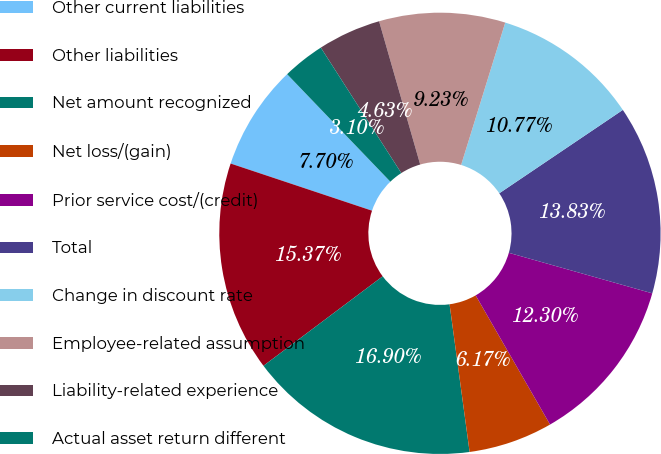Convert chart. <chart><loc_0><loc_0><loc_500><loc_500><pie_chart><fcel>Other current liabilities<fcel>Other liabilities<fcel>Net amount recognized<fcel>Net loss/(gain)<fcel>Prior service cost/(credit)<fcel>Total<fcel>Change in discount rate<fcel>Employee-related assumption<fcel>Liability-related experience<fcel>Actual asset return different<nl><fcel>7.7%<fcel>15.37%<fcel>16.9%<fcel>6.17%<fcel>12.3%<fcel>13.83%<fcel>10.77%<fcel>9.23%<fcel>4.63%<fcel>3.1%<nl></chart> 